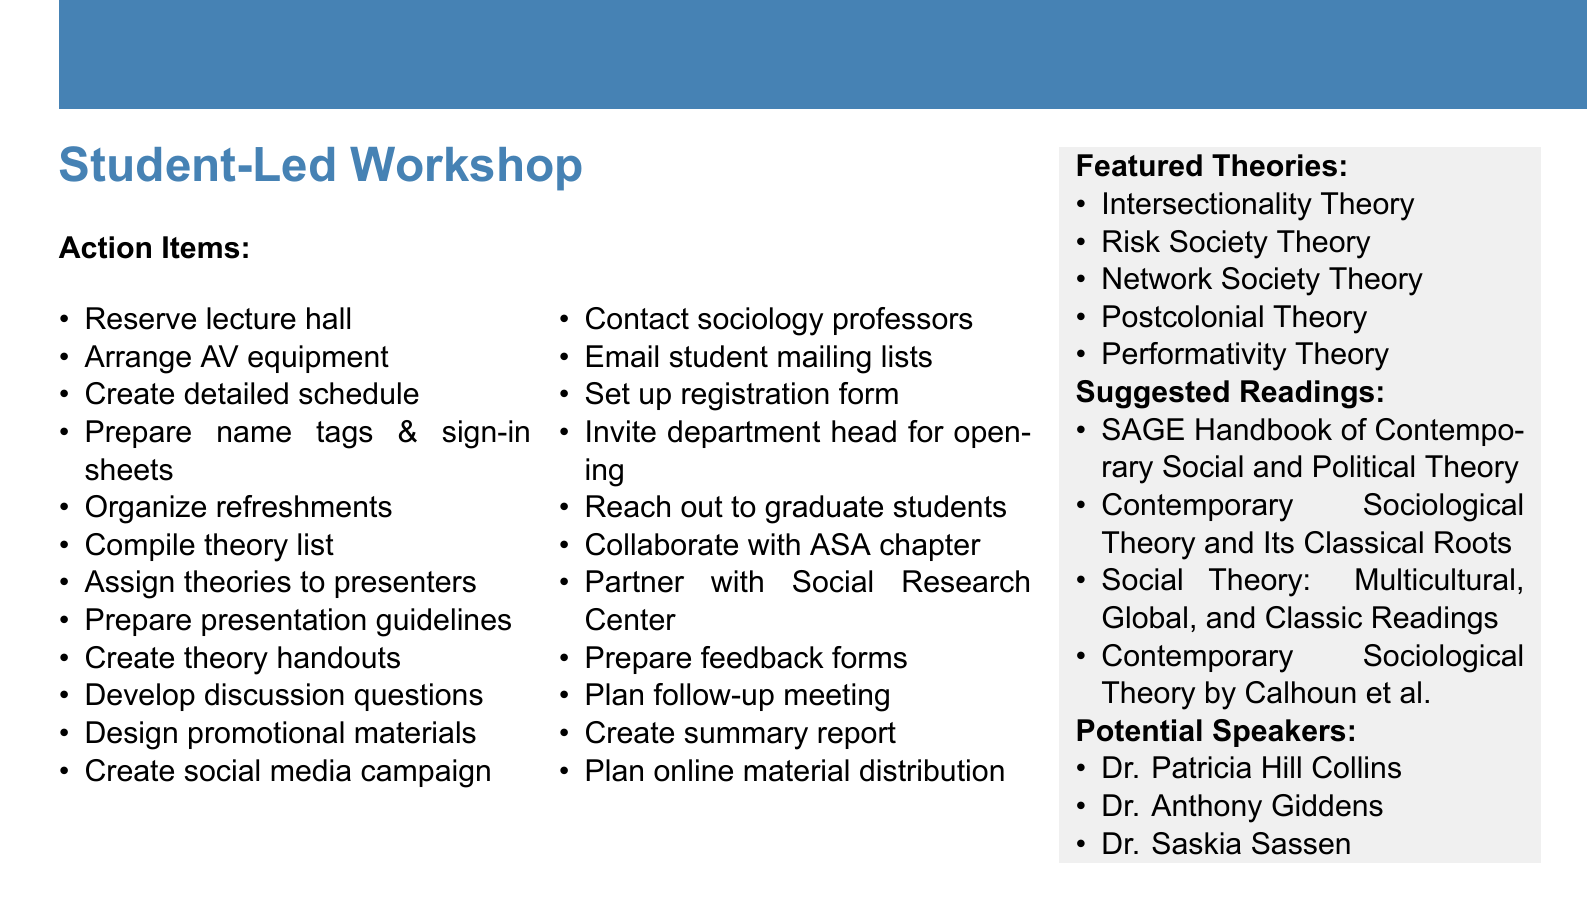what is the title of the workshop? The title of the workshop is mentioned at the beginning of the document as "Contemporary Sociological Theories: A Student-Led Exploration."
Answer: Contemporary Sociological Theories: A Student-Led Exploration how many action item categories are listed? The document contains five categories of action items: Logistics, Content Preparation, Participant Recruitment, Academic Collaboration, and Post-Workshop Activities.
Answer: five who is a potential guest speaker mentioned? The document lists potential guest speakers, and one of them is Dr. Patricia Hill Collins.
Answer: Dr. Patricia Hill Collins which theory is associated with Kimberlé Crenshaw? The document highlights "Intersectionality Theory by Kimberlé Crenshaw" as one of the featured theories.
Answer: Intersectionality Theory what is one of the suggested readings? The document suggests several readings, and one of them is "The SAGE Handbook of Contemporary Social and Political Theory."
Answer: The SAGE Handbook of Contemporary Social and Political Theory how many tasks are under logistics? There are five tasks listed under the Logistics category.
Answer: five which social media platforms are mentioned in the participant recruitment tasks? The document mentions using Instagram and Twitter as social media platforms for participant recruitment.
Answer: Instagram and Twitter what type of feedback is planned after the workshop? The document indicates that feedback forms will be prepared for participants to evaluate the workshop.
Answer: feedback forms 